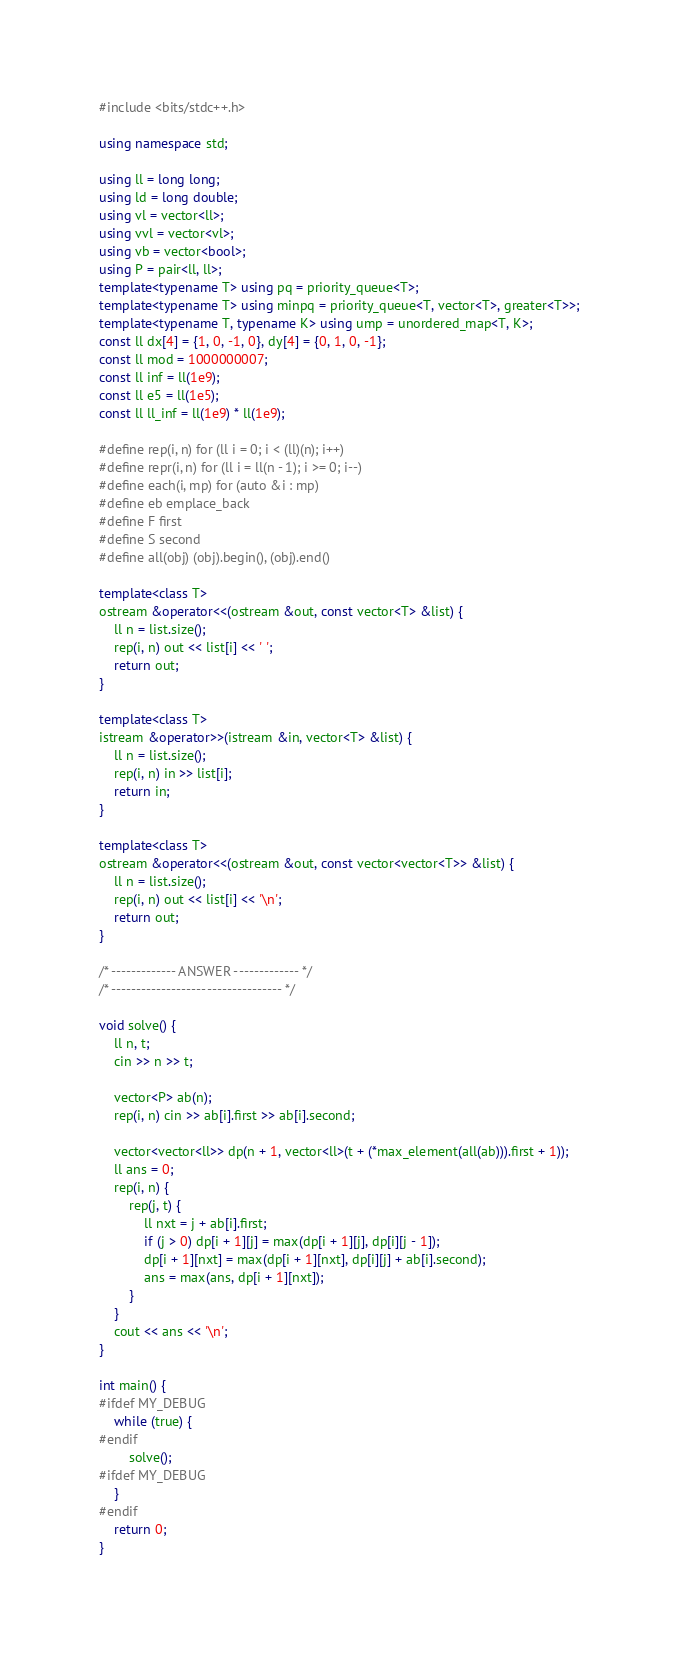Convert code to text. <code><loc_0><loc_0><loc_500><loc_500><_C++_>#include <bits/stdc++.h>

using namespace std;

using ll = long long;
using ld = long double;
using vl = vector<ll>;
using vvl = vector<vl>;
using vb = vector<bool>;
using P = pair<ll, ll>;
template<typename T> using pq = priority_queue<T>;
template<typename T> using minpq = priority_queue<T, vector<T>, greater<T>>;
template<typename T, typename K> using ump = unordered_map<T, K>;
const ll dx[4] = {1, 0, -1, 0}, dy[4] = {0, 1, 0, -1};
const ll mod = 1000000007;
const ll inf = ll(1e9);
const ll e5 = ll(1e5);
const ll ll_inf = ll(1e9) * ll(1e9);

#define rep(i, n) for (ll i = 0; i < (ll)(n); i++)
#define repr(i, n) for (ll i = ll(n - 1); i >= 0; i--)
#define each(i, mp) for (auto &i : mp)
#define eb emplace_back
#define F first
#define S second
#define all(obj) (obj).begin(), (obj).end()

template<class T>
ostream &operator<<(ostream &out, const vector<T> &list) {
    ll n = list.size();
    rep(i, n) out << list[i] << ' ';
    return out;
}

template<class T>
istream &operator>>(istream &in, vector<T> &list) {
    ll n = list.size();
    rep(i, n) in >> list[i];
    return in;
}

template<class T>
ostream &operator<<(ostream &out, const vector<vector<T>> &list) {
    ll n = list.size();
    rep(i, n) out << list[i] << '\n';
    return out;
}

/* ------------- ANSWER ------------- */
/* ---------------------------------- */

void solve() {
    ll n, t;
    cin >> n >> t;

    vector<P> ab(n);
    rep(i, n) cin >> ab[i].first >> ab[i].second;

    vector<vector<ll>> dp(n + 1, vector<ll>(t + (*max_element(all(ab))).first + 1));
    ll ans = 0;
    rep(i, n) {
        rep(j, t) {
            ll nxt = j + ab[i].first;
            if (j > 0) dp[i + 1][j] = max(dp[i + 1][j], dp[i][j - 1]);
            dp[i + 1][nxt] = max(dp[i + 1][nxt], dp[i][j] + ab[i].second);
            ans = max(ans, dp[i + 1][nxt]);
        }
    }
    cout << ans << '\n';
}

int main() {
#ifdef MY_DEBUG
    while (true) {
#endif
        solve();
#ifdef MY_DEBUG
    }
#endif
    return 0;
}</code> 